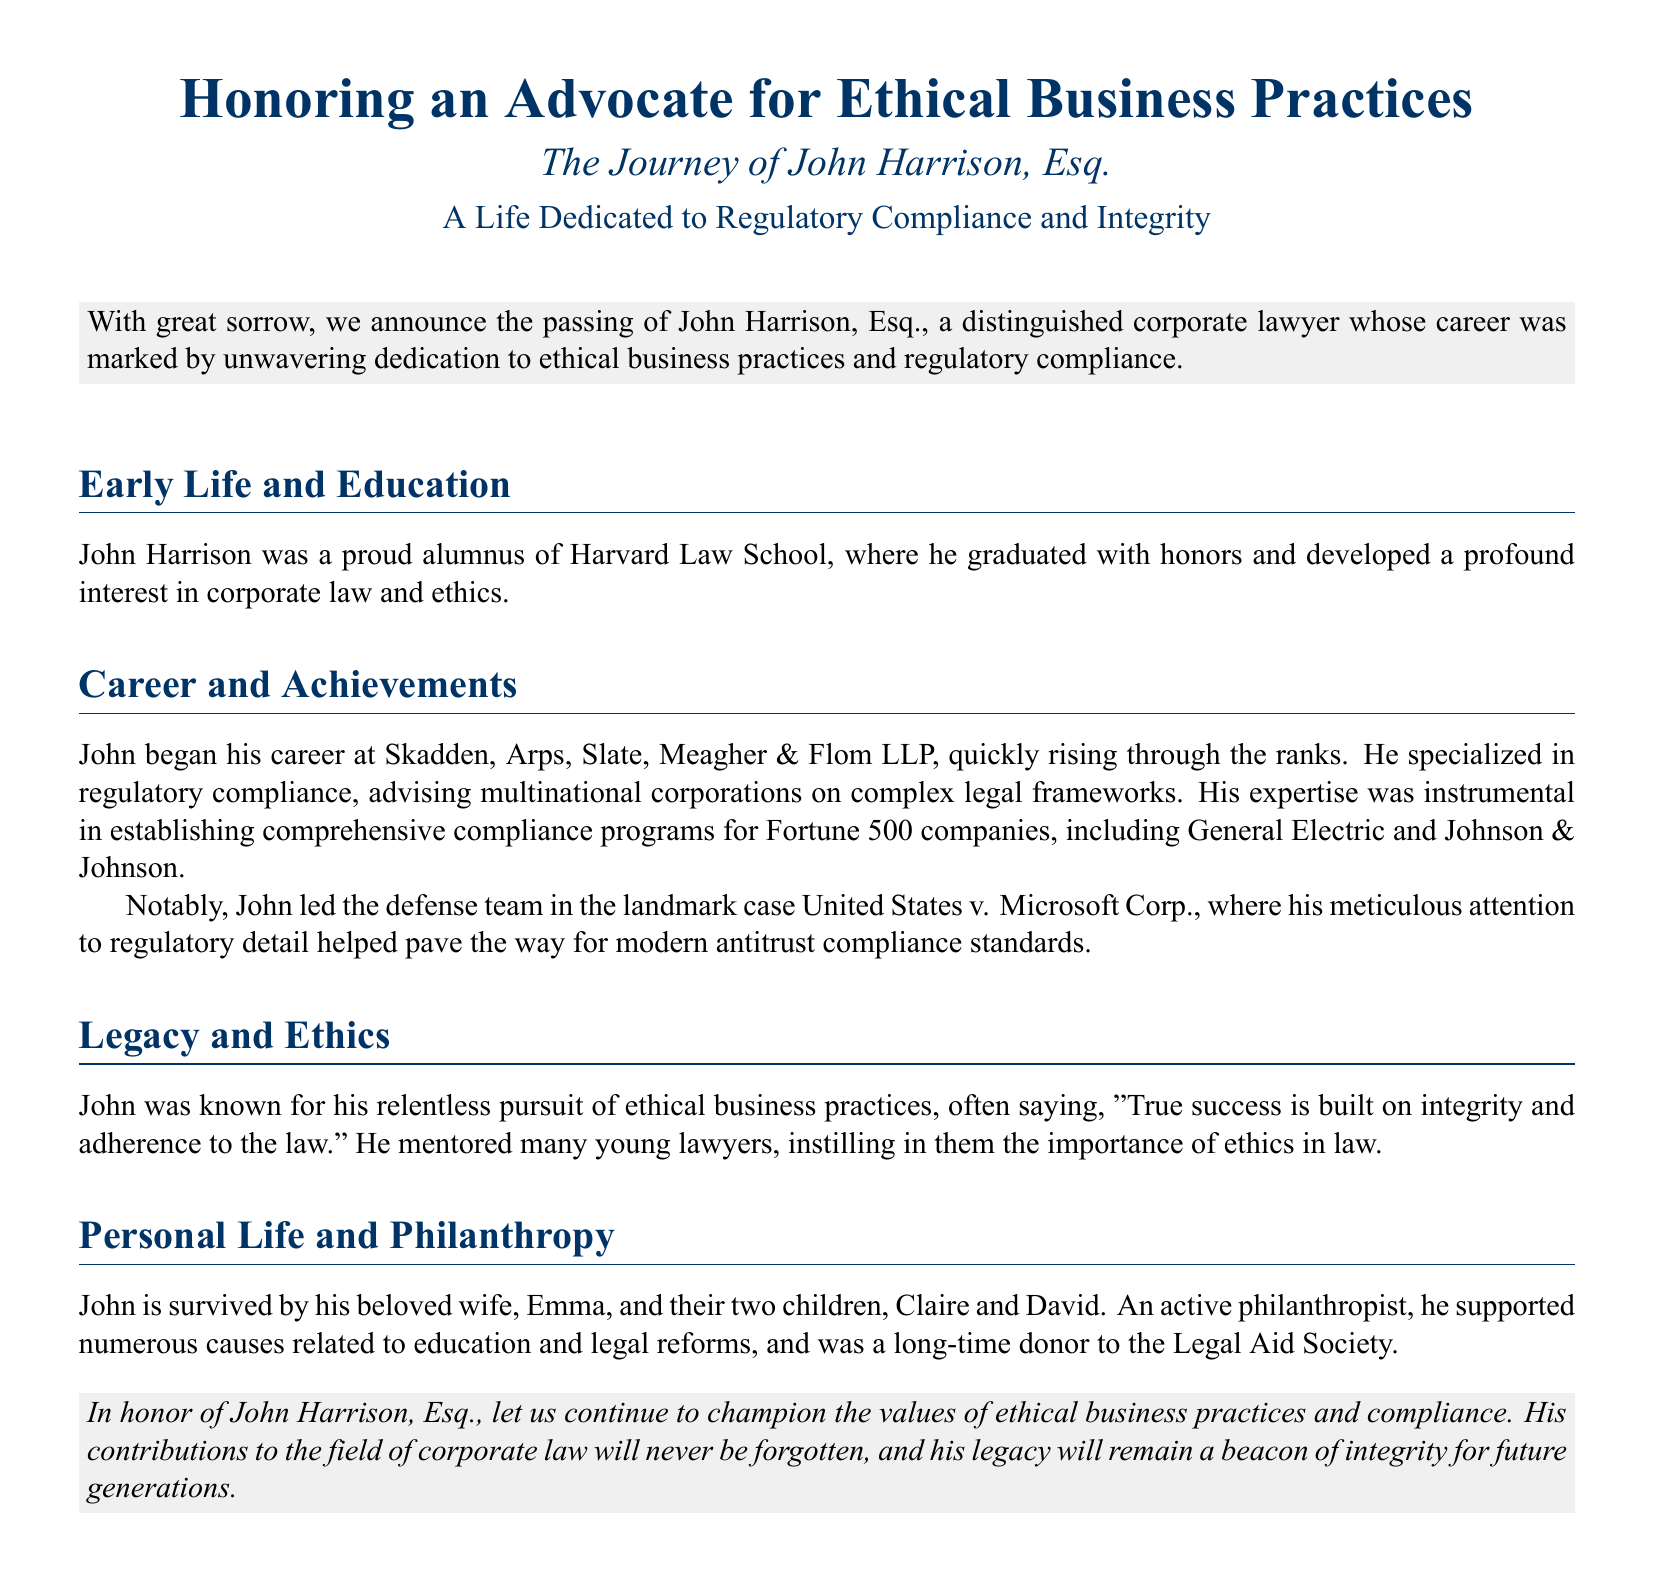What is the full name of the honoree? The document states the full name of the honoree as John Harrison, Esq.
Answer: John Harrison, Esq What law school did John Harrison graduate from? The document mentions that John Harrison was a proud alumnus of Harvard Law School.
Answer: Harvard Law School Which major companies did John assist with compliance programs? The document lists General Electric and Johnson & Johnson as companies for which John established compliance programs.
Answer: General Electric and Johnson & Johnson What landmark case did John lead the defense team for? The document refers to the landmark case as United States v. Microsoft Corp.
Answer: United States v. Microsoft Corp What was John Harrison's advice about success? The document states that John believed "True success is built on integrity and adherence to the law."
Answer: True success is built on integrity and adherence to the law How many children did John Harrison have? The document mentions that John is survived by two children, Claire and David.
Answer: Two children What philanthropic cause was John known to support? The document notes that John was a long-time donor to the Legal Aid Society, which is a cause related to legal reforms.
Answer: Legal Aid Society Who survives John Harrison? The document states that John is survived by his wife, Emma, and their two children.
Answer: Emma, Claire, and David 